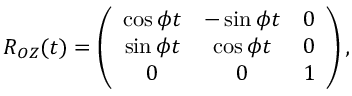<formula> <loc_0><loc_0><loc_500><loc_500>\begin{array} { r } { R _ { O Z } ( t ) = \left ( \begin{array} { c c c } { \cos \phi t } & { - \sin \phi t } & { 0 } \\ { \sin \phi t } & { \cos \phi t } & { 0 } \\ { 0 } & { 0 } & { 1 } \end{array} \right ) , } \end{array}</formula> 